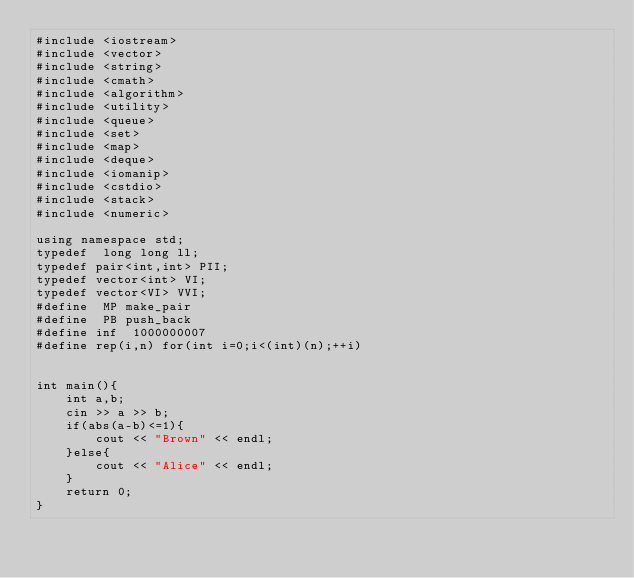<code> <loc_0><loc_0><loc_500><loc_500><_C++_>#include <iostream>
#include <vector>
#include <string>
#include <cmath>
#include <algorithm>
#include <utility>
#include <queue>
#include <set>
#include <map>
#include <deque>
#include <iomanip>
#include <cstdio>
#include <stack>
#include <numeric>

using namespace std;
typedef  long long ll;
typedef pair<int,int> PII;
typedef vector<int> VI;
typedef vector<VI> VVI;
#define  MP make_pair
#define  PB push_back
#define inf  1000000007
#define rep(i,n) for(int i=0;i<(int)(n);++i)


int main(){
    int a,b;
    cin >> a >> b;
    if(abs(a-b)<=1){
        cout << "Brown" << endl;
    }else{
        cout << "Alice" << endl;
    }
    return 0;
}</code> 